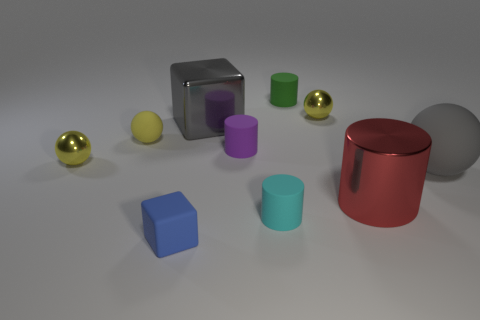Subtract all green cubes. How many yellow balls are left? 3 Subtract 1 spheres. How many spheres are left? 3 Subtract all cylinders. How many objects are left? 6 Subtract all tiny purple things. Subtract all green objects. How many objects are left? 8 Add 7 small green cylinders. How many small green cylinders are left? 8 Add 1 small cubes. How many small cubes exist? 2 Subtract 0 yellow cylinders. How many objects are left? 10 